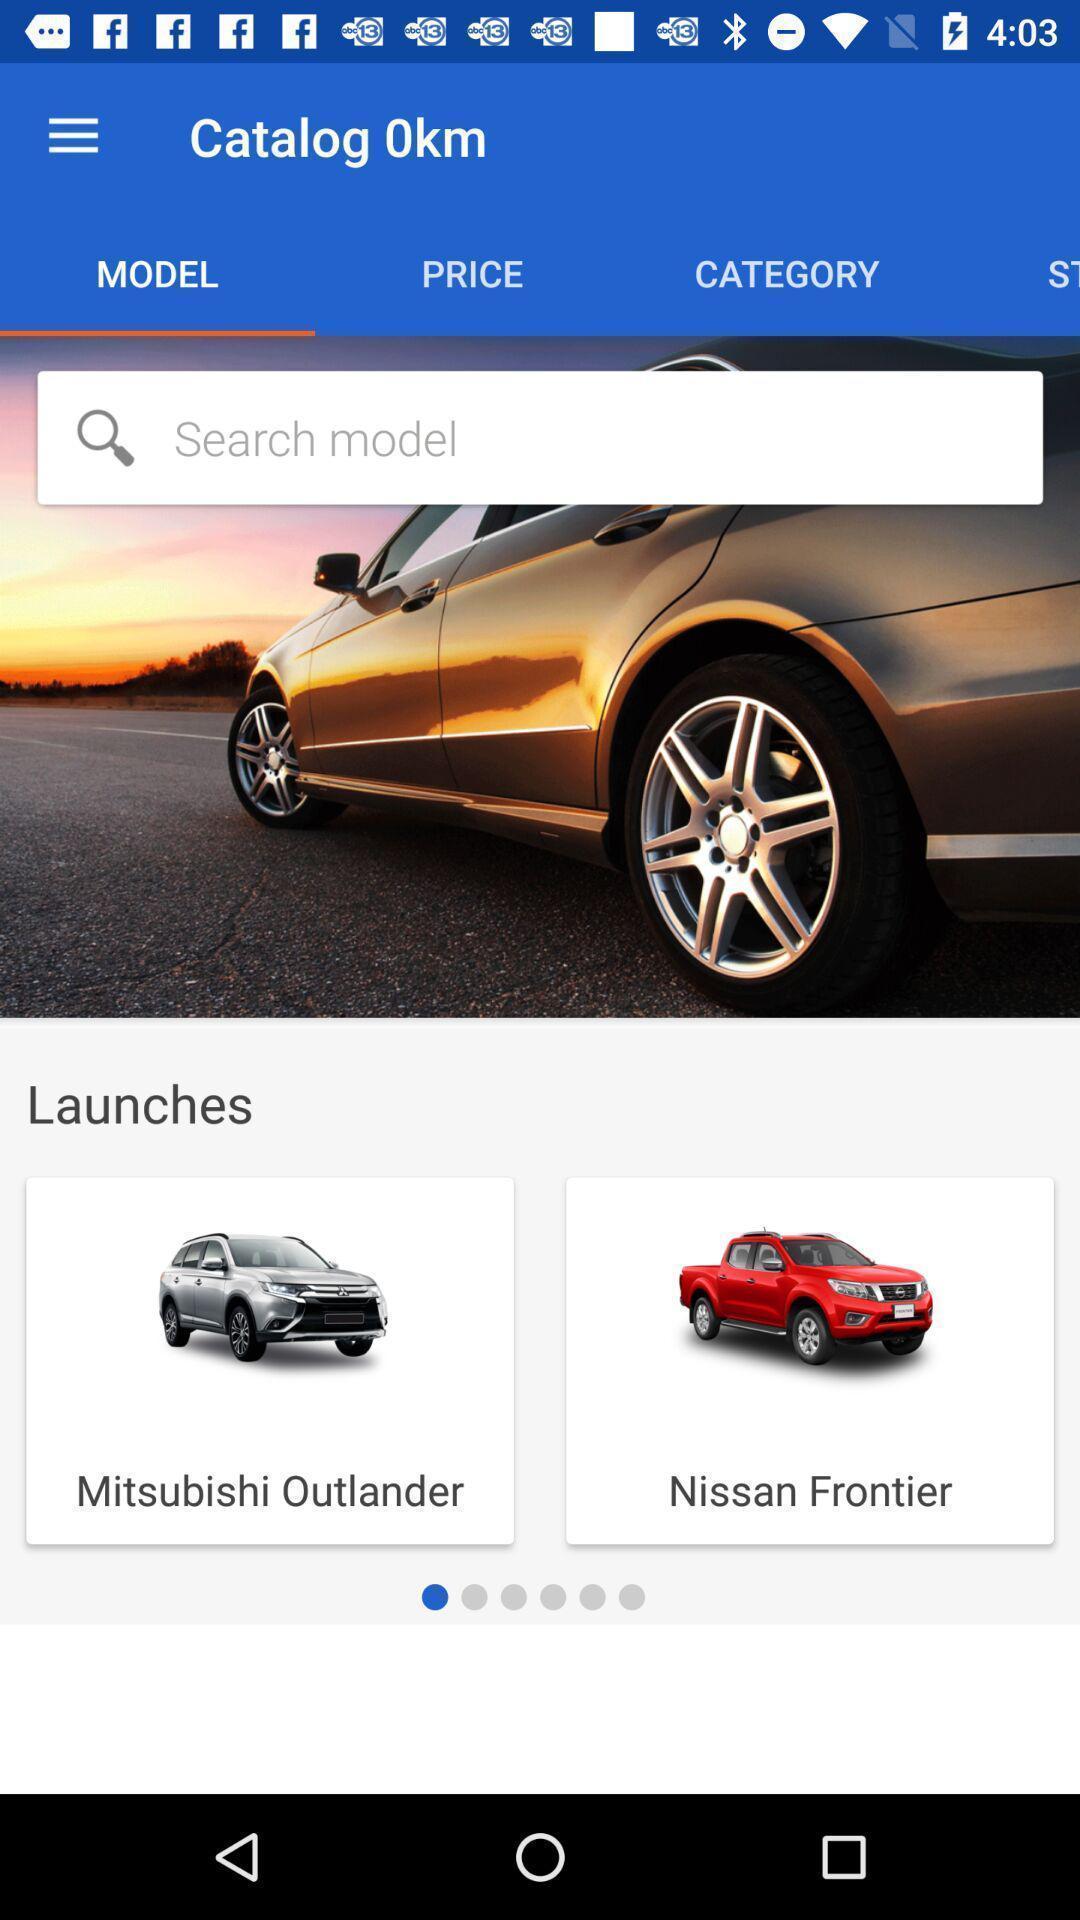Explain the elements present in this screenshot. Search page of a cars sale app. 